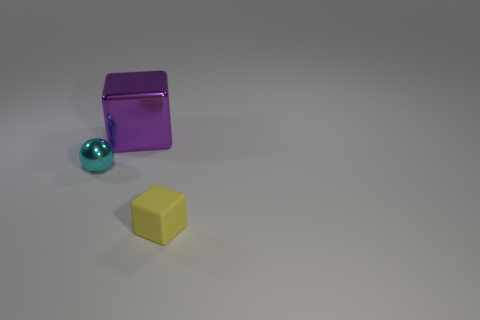Are there any shadows in the image, and if so, what can they tell us about the light source? Yes, there are shadows visible behind each of the objects. The shadows are soft and extend directly away from the objects, indicating that the light source is above and in front of them. This placement creates a sense of depth and enhances the three-dimensionality of the objects. 